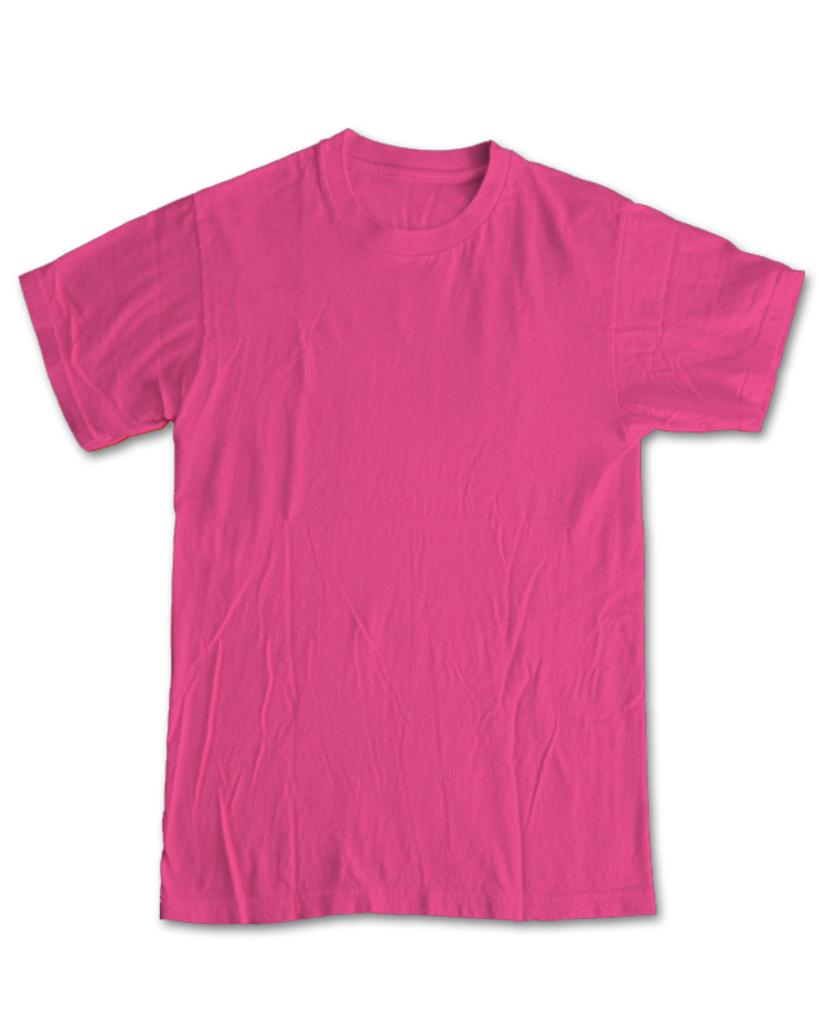What type of clothing item is in the image? There is a T-shirt in the image. What color is the T-shirt? The T-shirt is pink in color. What color is the background of the image? The background of the image is white. How many birds are flying in the image? There are no birds present in the image. What year is depicted in the image? The image does not depict a specific year. 